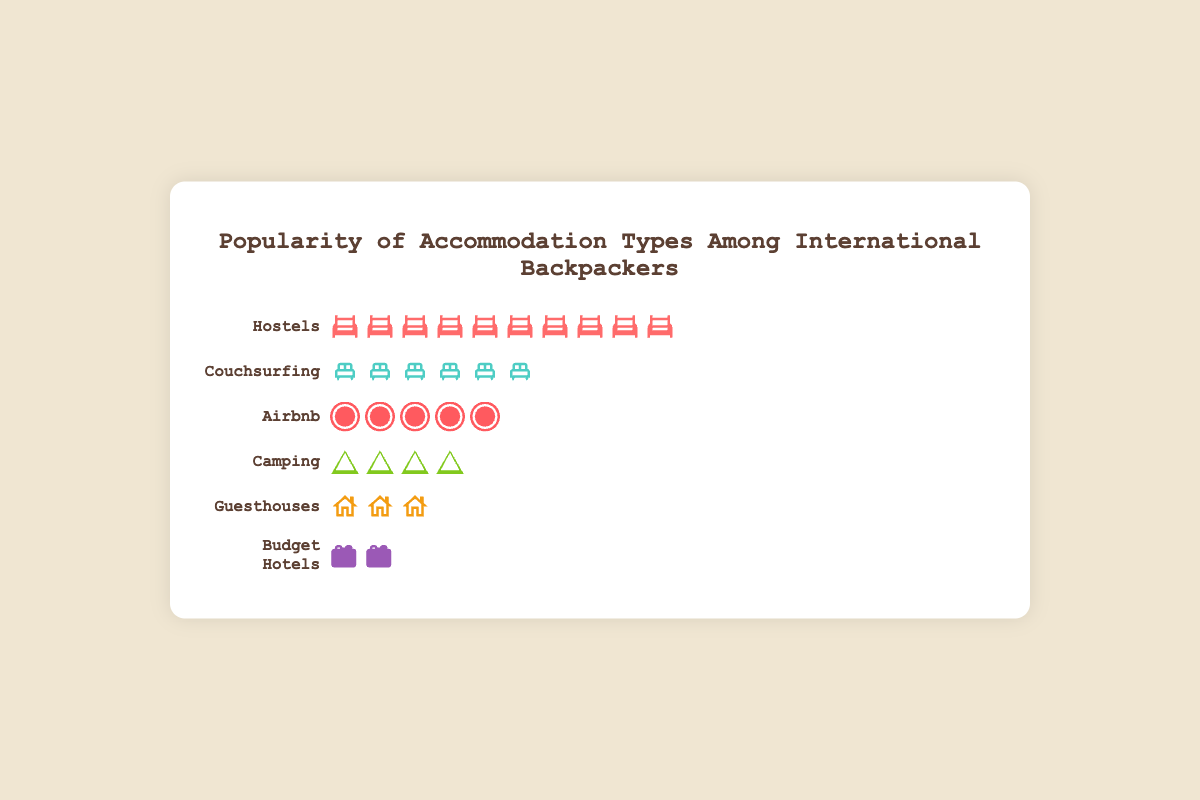Which accommodation type is the most popular among international backpackers? By counting the number of icons representing each accommodation type, "Hostels" have the most icons (50), indicating it is the most popular.
Answer: Hostels What is the difference in popularity between the most and least popular accommodation types? The most popular accommodation type is "Hostels" with 50 icons, and the least popular is "Budget Hotels" with 10 icons. The difference is 50 - 10 = 40.
Answer: 40 How many more icons does Couchsurfing have compared to Budget Hotels? "Couchsurfing" has 30 icons and "Budget Hotels" have 10 icons. The difference is 30 - 10 = 20.
Answer: 20 Which accommodation type is more popular, Airbnb or Camping? And by how much? "Airbnb" has 25 icons whereas "Camping" has 20 icons. "Airbnb" is more popular by 25 - 20 = 5 icons.
Answer: Airbnb, 5 What is the total number of backpackers represented in the figure? The total number of backpackers is the sum of icons for each accommodation type: 50 (Hostels) + 30 (Couchsurfing) + 25 (Airbnb) + 20 (Camping) + 15 (Guesthouses) + 10 (Budget Hotels) = 150.
Answer: 150 Between which two accommodation types is the difference in popularity exactly 5 backpackers? The only pair with a difference of 5 is "Airbnb" with 25 icons and "Camping" with 20 icons.
Answer: Airbnb and Camping What is the average number of backpackers per accommodation type? The total number of backpackers is 150, and there are 6 accommodation types. The average is 150 / 6 = 25.
Answer: 25 Which accommodation type has the fewest icons? By counting the number of icons, "Budget Hotels" has the fewest icons with 10.
Answer: Budget Hotels By what percentage is Couchsurfing more popular than Budget Hotels? "Couchsurfing" has 30 icons, and "Budget Hotels" have 10 icons. The percentage increase is calculated as ((30 - 10) / 10) * 100 = 200%.
Answer: 200% 